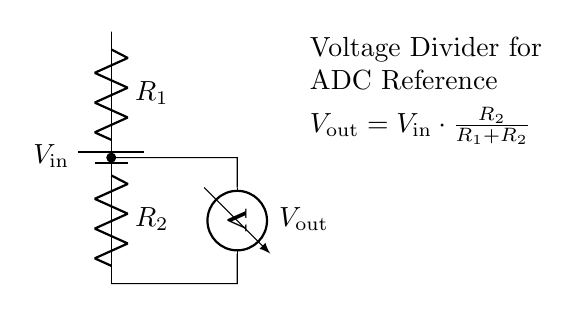What is the input voltage in the circuit? The input voltage, represented as \( V_\text{in} \), is connected to the top of the battery symbol in the circuit. It indicates the voltage supplied to the voltage divider.
Answer: \( V_\text{in} \) What components are used in this voltage divider? The circuit contains two resistors labeled \( R_1 \) and \( R_2 \), and a voltmeter indicating the output voltage \( V_\text{out} \). These components are interconnected to create the voltage divider function.
Answer: \( R_1 \), \( R_2 \) What does the output voltage depend on? The output voltage \( V_\text{out} \) depends on the input voltage \( V_\text{in} \) and the values of the resistors \( R_1 \) and \( R_2 \), following the formula provided in the diagram.
Answer: Resistor values and \( V_\text{in} \) What is the formula for the output voltage? The output voltage can be calculated using the formula \( V_\text{out} = V_\text{in} \cdot \frac{R_2}{R_1 + R_2} \), which describes how the input voltage is divided across the resistors.
Answer: \( V_\text{out} = V_\text{in} \cdot \frac{R_2}{R_1 + R_2} \) How does increasing \( R_2 \) affect \( V_\text{out} \)? Increasing \( R_2 \) increases the portion of the total resistance, leading to a higher \( V_\text{out} \) based on the voltage divider principle. The ratio \( \frac{R_2}{R_1 + R_2} \) becomes larger, resulting in a greater output voltage.
Answer: Increases \( V_\text{out} \) What does a voltmeter measure in this circuit? The voltmeter is used to measure the output voltage \( V_\text{out} \) across the resistor \( R_2 \). This provides feedback on how much of the input voltage is present after the voltage division.
Answer: Output voltage \( V_\text{out} \) 